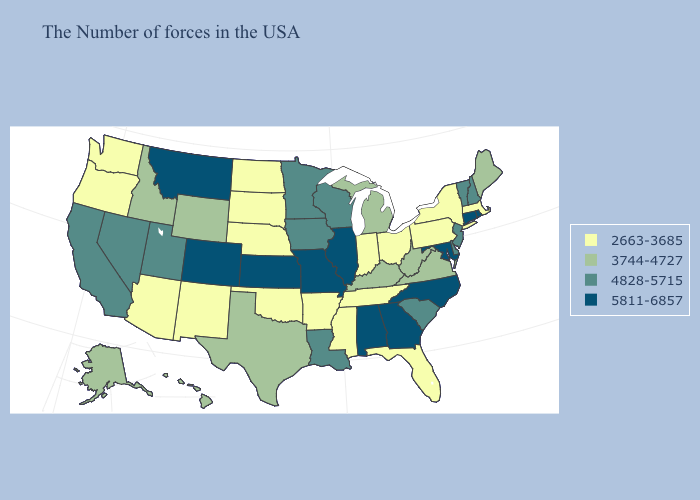What is the value of Louisiana?
Quick response, please. 4828-5715. Which states have the highest value in the USA?
Be succinct. Rhode Island, Connecticut, Maryland, North Carolina, Georgia, Alabama, Illinois, Missouri, Kansas, Colorado, Montana. Does Pennsylvania have the highest value in the Northeast?
Give a very brief answer. No. Name the states that have a value in the range 5811-6857?
Give a very brief answer. Rhode Island, Connecticut, Maryland, North Carolina, Georgia, Alabama, Illinois, Missouri, Kansas, Colorado, Montana. Name the states that have a value in the range 4828-5715?
Quick response, please. New Hampshire, Vermont, New Jersey, Delaware, South Carolina, Wisconsin, Louisiana, Minnesota, Iowa, Utah, Nevada, California. Name the states that have a value in the range 3744-4727?
Answer briefly. Maine, Virginia, West Virginia, Michigan, Kentucky, Texas, Wyoming, Idaho, Alaska, Hawaii. Does the map have missing data?
Write a very short answer. No. Does Missouri have the lowest value in the USA?
Short answer required. No. What is the value of California?
Be succinct. 4828-5715. Does Hawaii have a higher value than Utah?
Give a very brief answer. No. What is the value of Alabama?
Be succinct. 5811-6857. Does Maine have the same value as Virginia?
Answer briefly. Yes. Name the states that have a value in the range 2663-3685?
Concise answer only. Massachusetts, New York, Pennsylvania, Ohio, Florida, Indiana, Tennessee, Mississippi, Arkansas, Nebraska, Oklahoma, South Dakota, North Dakota, New Mexico, Arizona, Washington, Oregon. Among the states that border Tennessee , which have the highest value?
Short answer required. North Carolina, Georgia, Alabama, Missouri. Name the states that have a value in the range 4828-5715?
Concise answer only. New Hampshire, Vermont, New Jersey, Delaware, South Carolina, Wisconsin, Louisiana, Minnesota, Iowa, Utah, Nevada, California. 